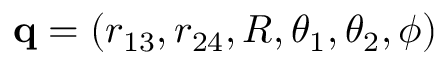Convert formula to latex. <formula><loc_0><loc_0><loc_500><loc_500>{ q } = ( r _ { 1 3 } , r _ { 2 4 } , R , \theta _ { 1 } , \theta _ { 2 } , \phi )</formula> 